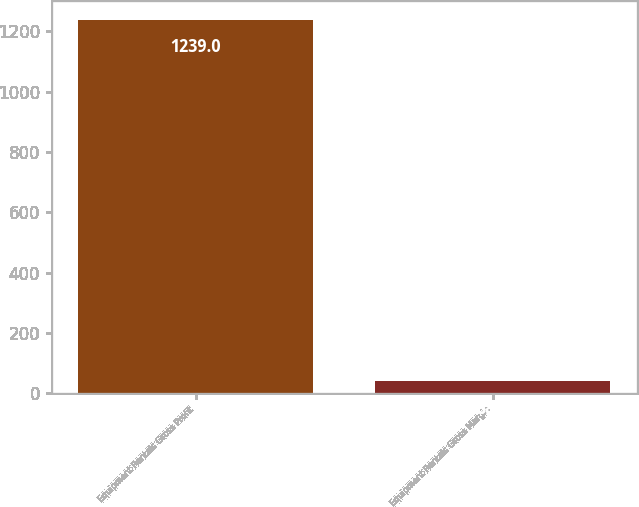<chart> <loc_0><loc_0><loc_500><loc_500><bar_chart><fcel>Equipment Rentals Gross Profit<fcel>Equipment Rentals Gross Margin<nl><fcel>1239<fcel>38.9<nl></chart> 